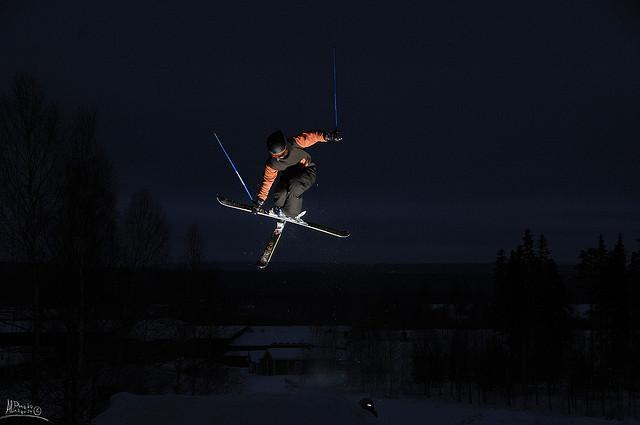How many people in the boat are wearing life jackets?
Give a very brief answer. 0. 